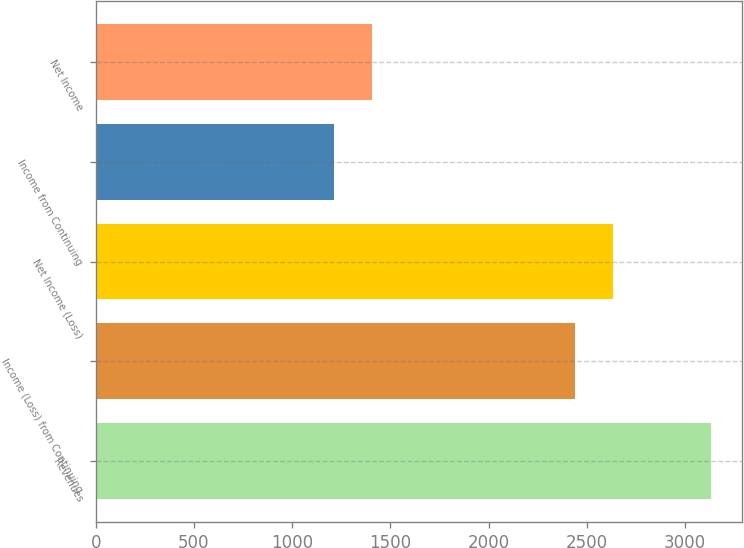Convert chart to OTSL. <chart><loc_0><loc_0><loc_500><loc_500><bar_chart><fcel>Revenues<fcel>Income (Loss) from Continuing<fcel>Net Income (Loss)<fcel>Income from Continuing<fcel>Net Income<nl><fcel>3133<fcel>2441<fcel>2632.9<fcel>1214<fcel>1405.9<nl></chart> 